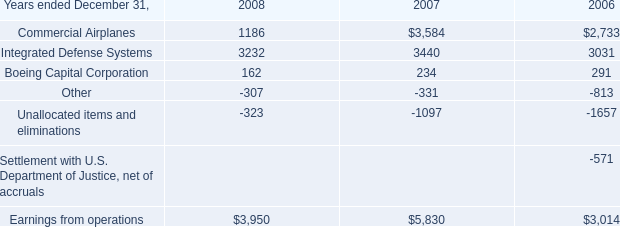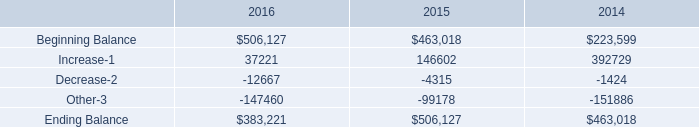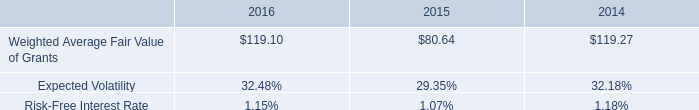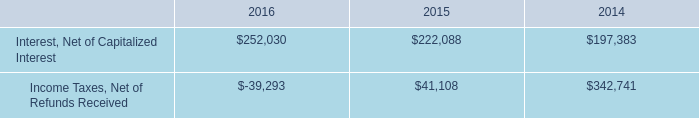considering the balance of unrecognized tax benefits in 2016 , what is the percentage of the potential of tax benefits that may have an earnings impact? 
Computations: (2 / 36)
Answer: 0.05556. 